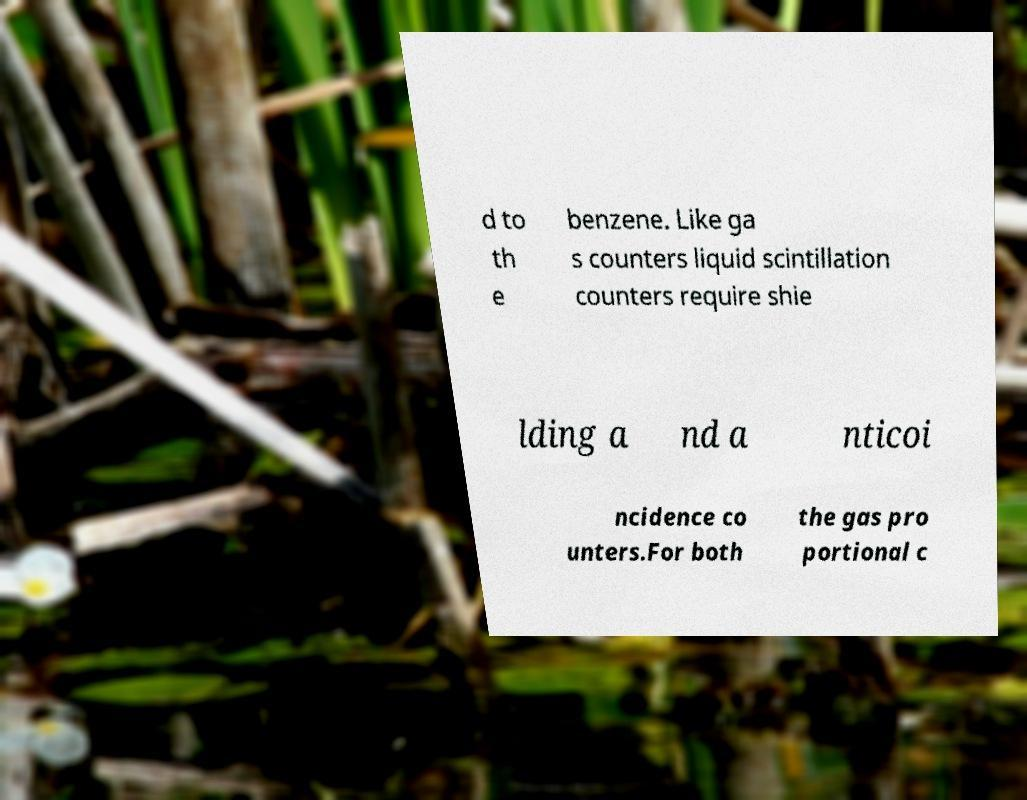Please read and relay the text visible in this image. What does it say? d to th e benzene. Like ga s counters liquid scintillation counters require shie lding a nd a nticoi ncidence co unters.For both the gas pro portional c 